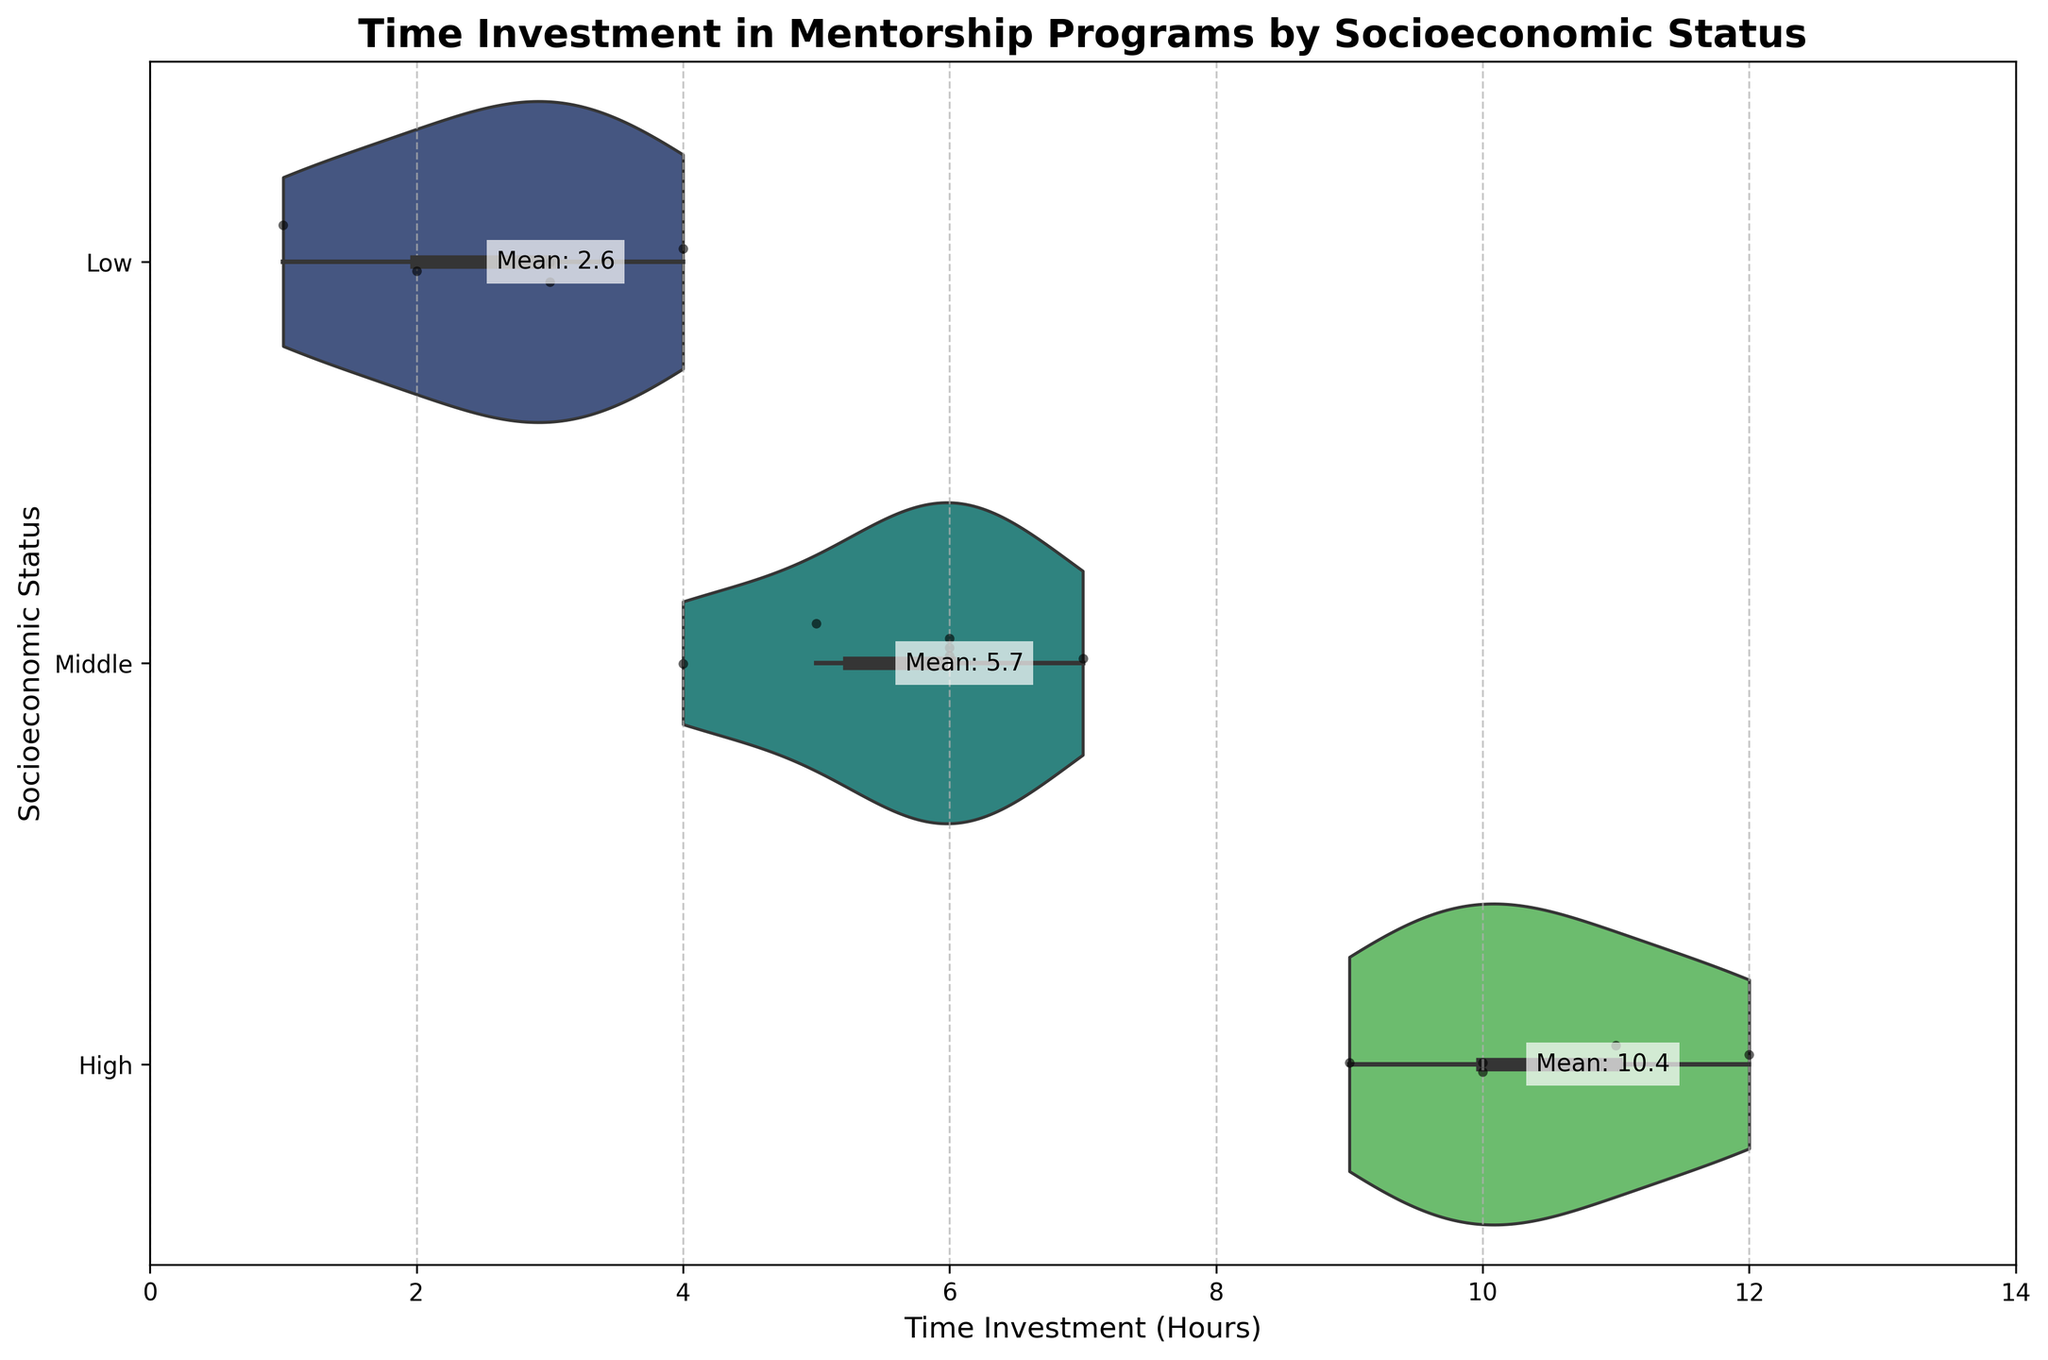What is the title of the figure? The title is typically found at the top of the figure and provides a summary of what the chart is about.
Answer: "Time Investment in Mentorship Programs by Socioeconomic Status" What does the x-axis represent? The x-axis label provides information on what the variable plotted along the horizontal axis is.
Answer: "Time Investment (Hours)" How many socioeconomic status groups are represented in the chart? By looking at the y-axis, we can count the number of distinct groups listed. In this case, there are three socioeconomic status groups.
Answer: 3 Which socioeconomic status group invests the most time on average in mentorship programs? By comparing the position of the mean annotation (text) for each group, we see which one has the highest mean time investment. The mean time is highest for the High socioeconomic status group.
Answer: High What is the mean time investment for the Low socioeconomic status group? According to the text annotation by the Low socioeconomic status group's violin plot, the mean time investment is shown.
Answer: 2.6 hours How does the distribution of time investment differ between the Low and High socioeconomic status groups? By comparing the width and spread of the violin plots for both groups, we notice that the High group shows a wider range and higher values for time investment, while the Low group has a narrower range centered on lower values.
Answer: High group has higher and more varied distribution compared to the Low group Which program has the widest distribution of time investment in the High socioeconomic status group? By observing the width and spread of the inner violin plot markings for each program within the High socioeconomic status group, we notice the broader range.
Answer: "InspireYouth" Compare the median time investment between the Middle and High socioeconomic status groups. To find the median, we look at the central horizontal line within the box in each violin plot. The median for Middle is around 5.5 hours, while for High it is around 10 hours. Thus, the High group has a higher median time investment.
Answer: High has a higher median time investment How does the range of time investment in the Middle socioeconomic status group compare to the Low group? By observing the extent of the violin plots along the x-axis, the Middle socioeconomic status group ranges from approximately 4 to 7 hours, while the Low group ranges from approximately 1 to 4 hours, showing that the Middle group has a slightly wider range.
Answer: Middle group has a wider range Looking at the jittered points, which socioeconomic status group shows the most variability in time investment? By visual inspection of the spread of jittered (strip plot) points, we see that the High socioeconomic status group has points spread across a wider range compared to Low and Middle groups.
Answer: High 